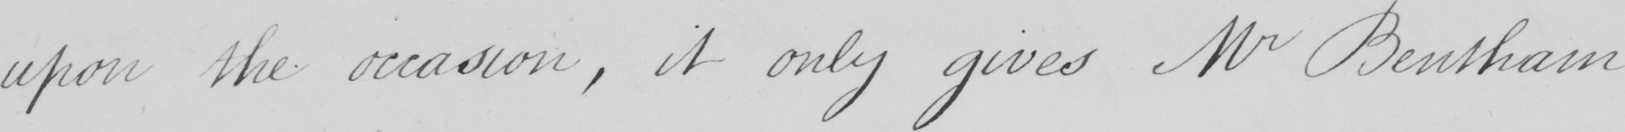Please provide the text content of this handwritten line. upon the occasion , it only gives Mr Bentham 